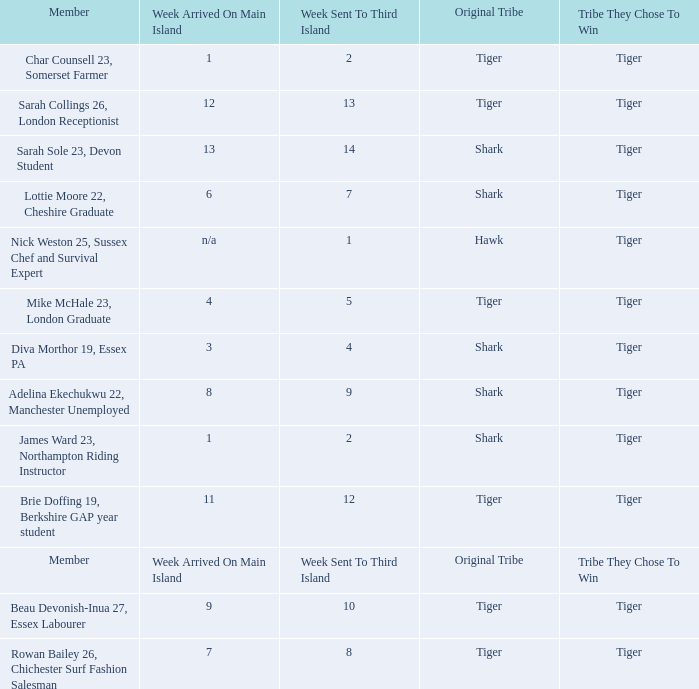What week was the member who arrived on the main island in week 6 sent to the third island? 7.0. 